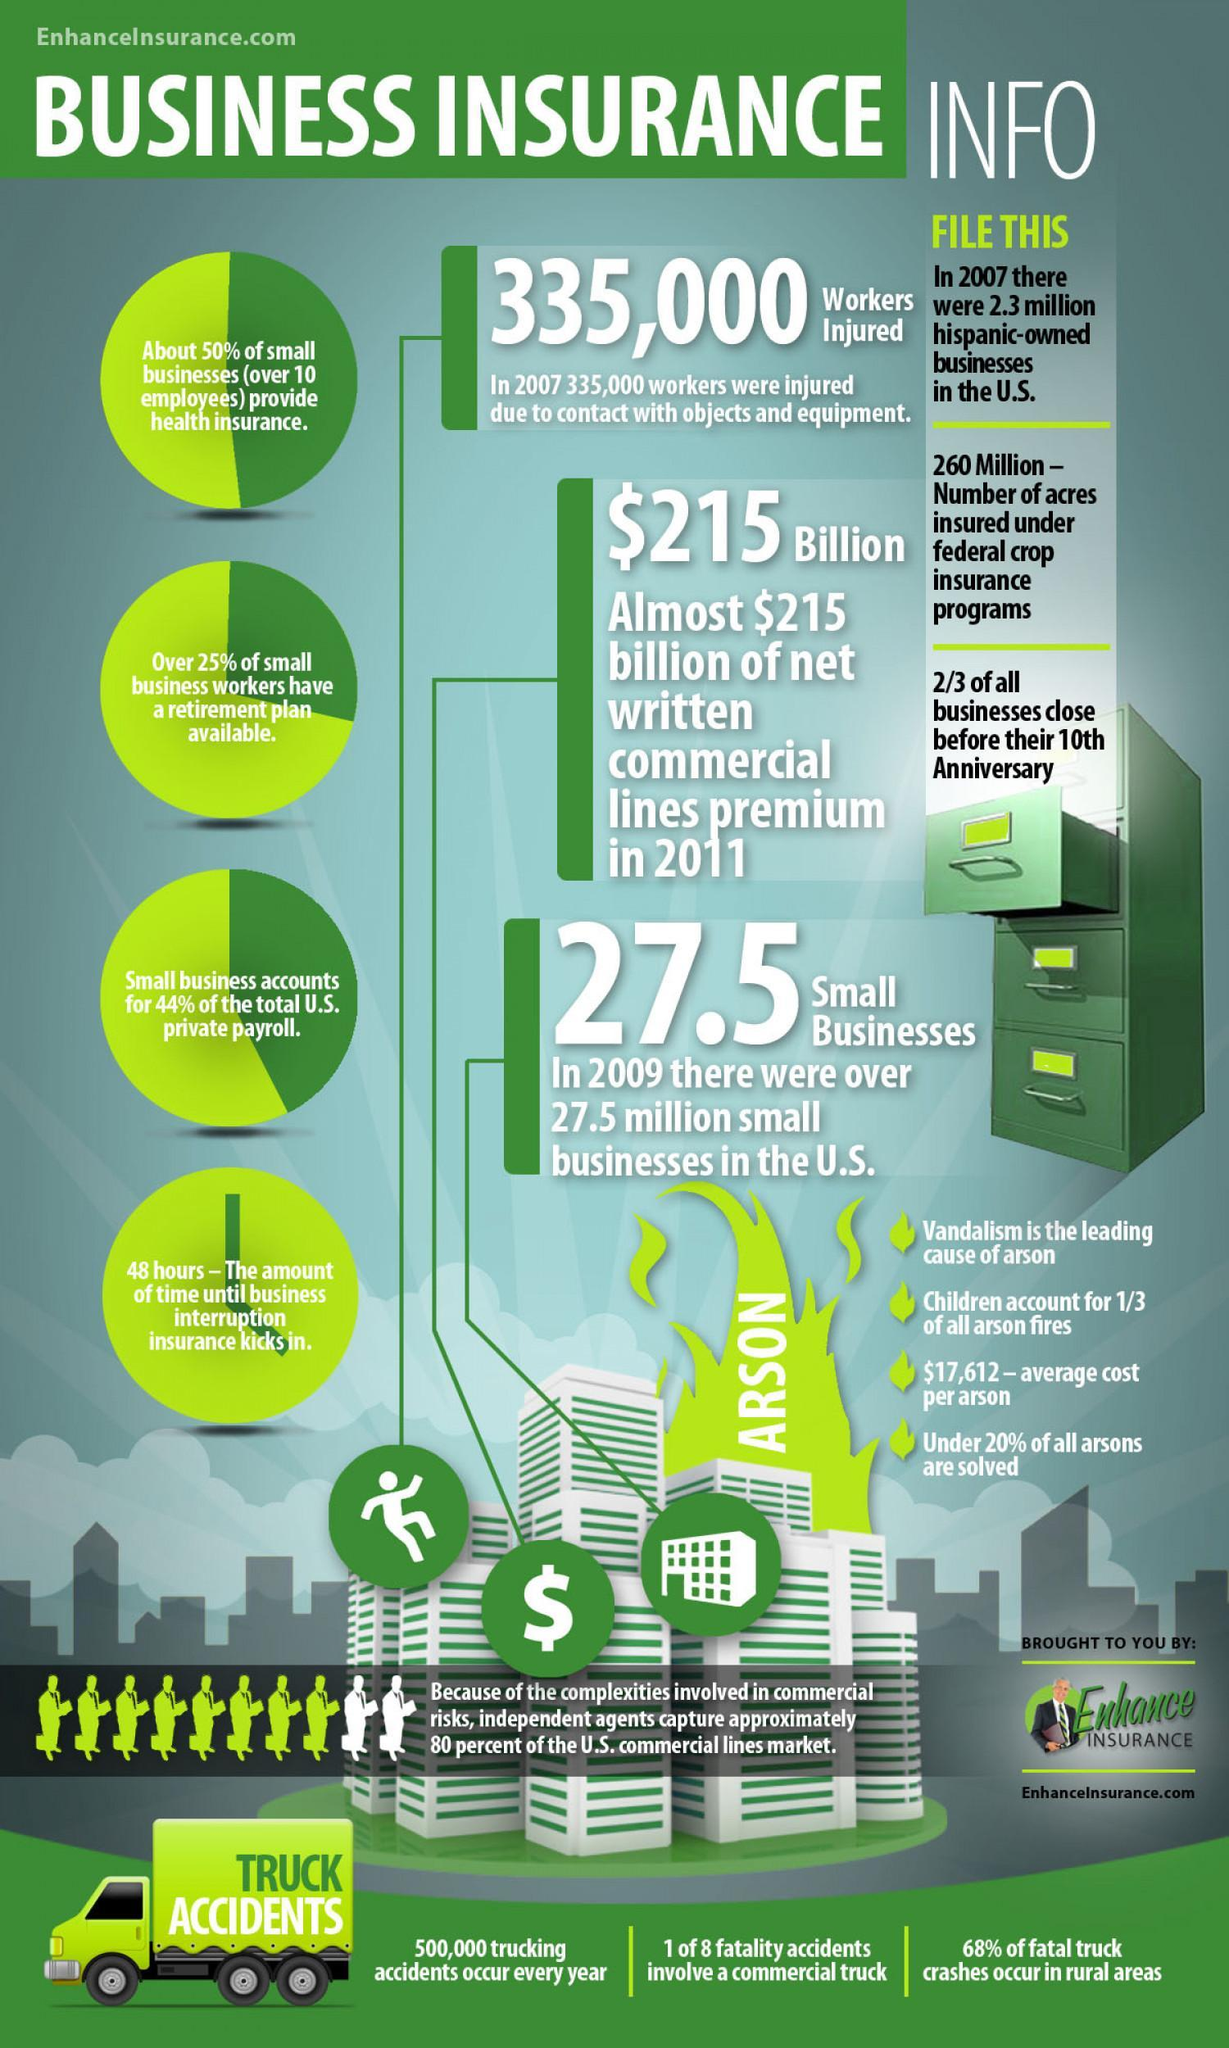how many accidents occur due to trucks
Answer the question with a short phrase. 500,000 how many hispanic owned businesses 2.3 million how many acres insured 260 Million what causes 1 of 8 fatality accidents commercial truck how long does it take for insurance to kick in 48 hours how many small business workers have a retirement plan over 25% who cause 1/3 of arson fire children how many business survive after their 10th anniversary 1/3 